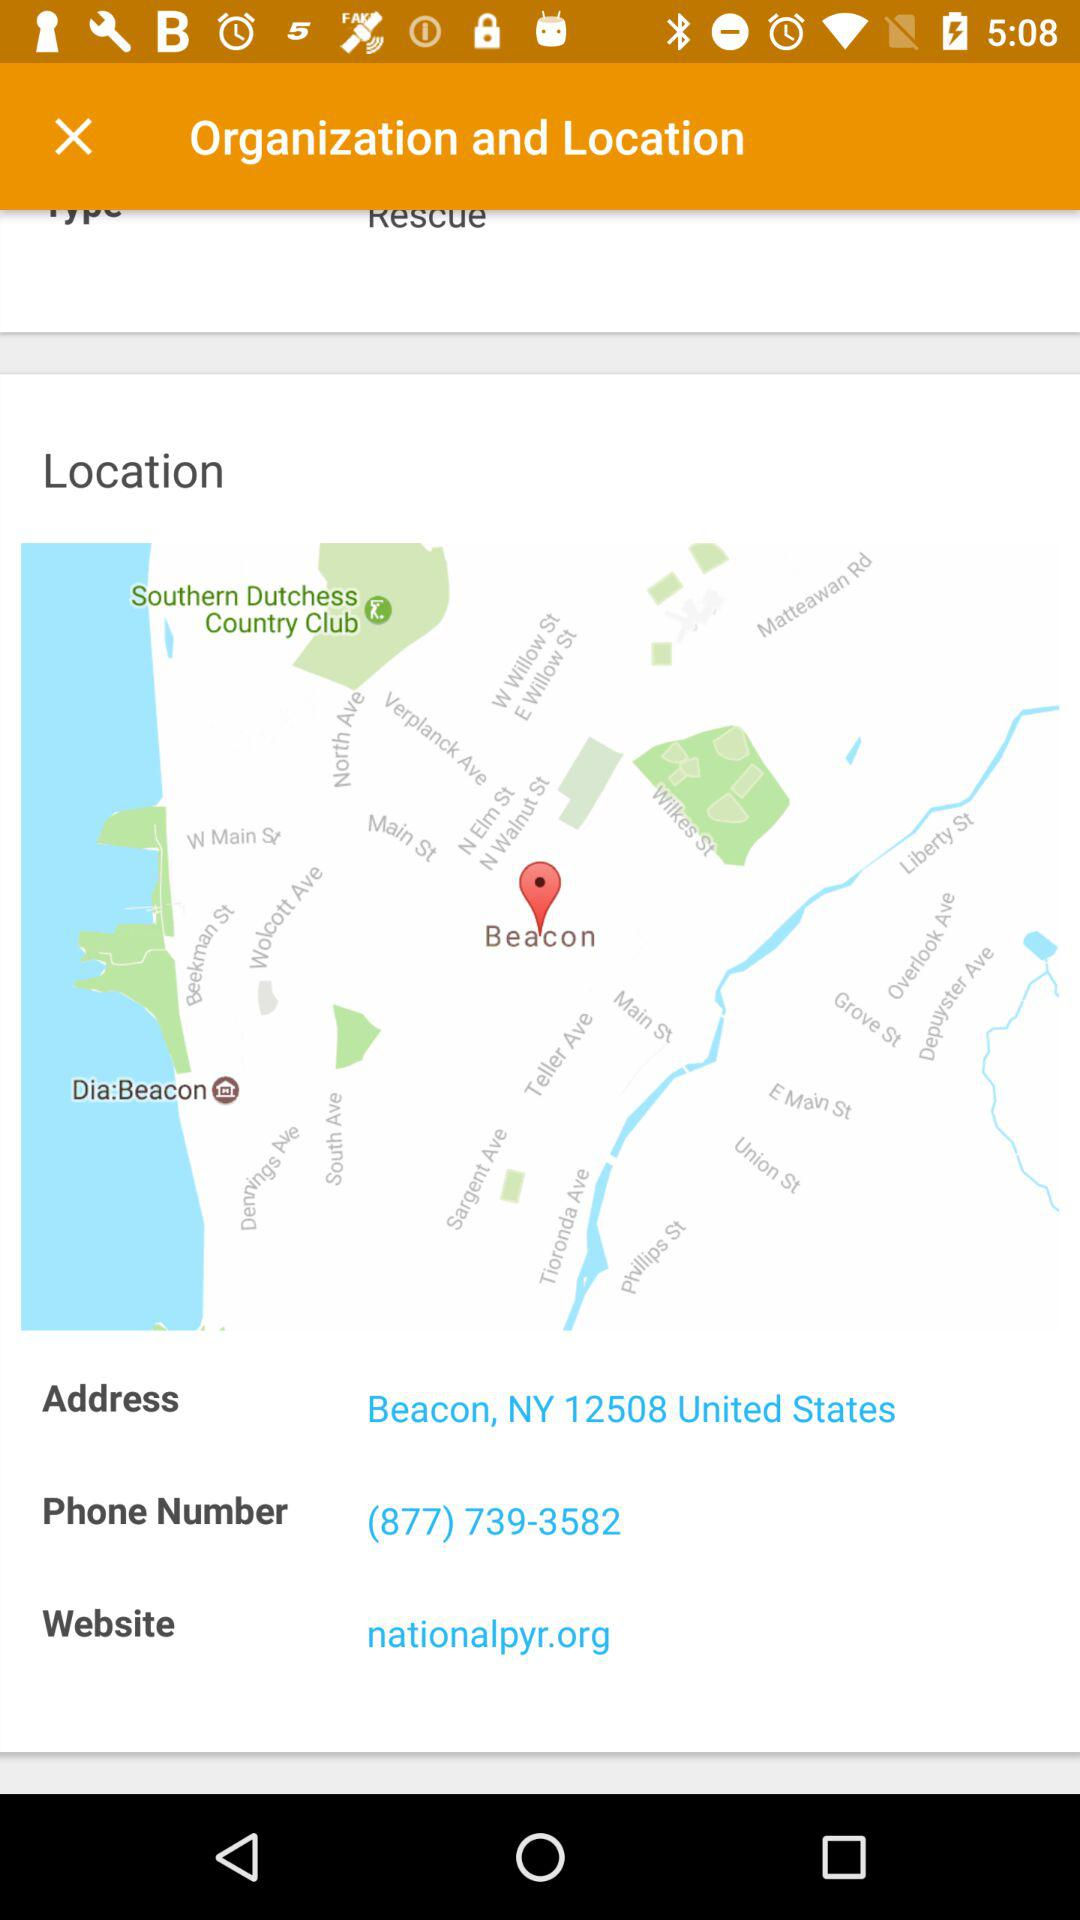What is the website? The website is nationalpyr.org. 